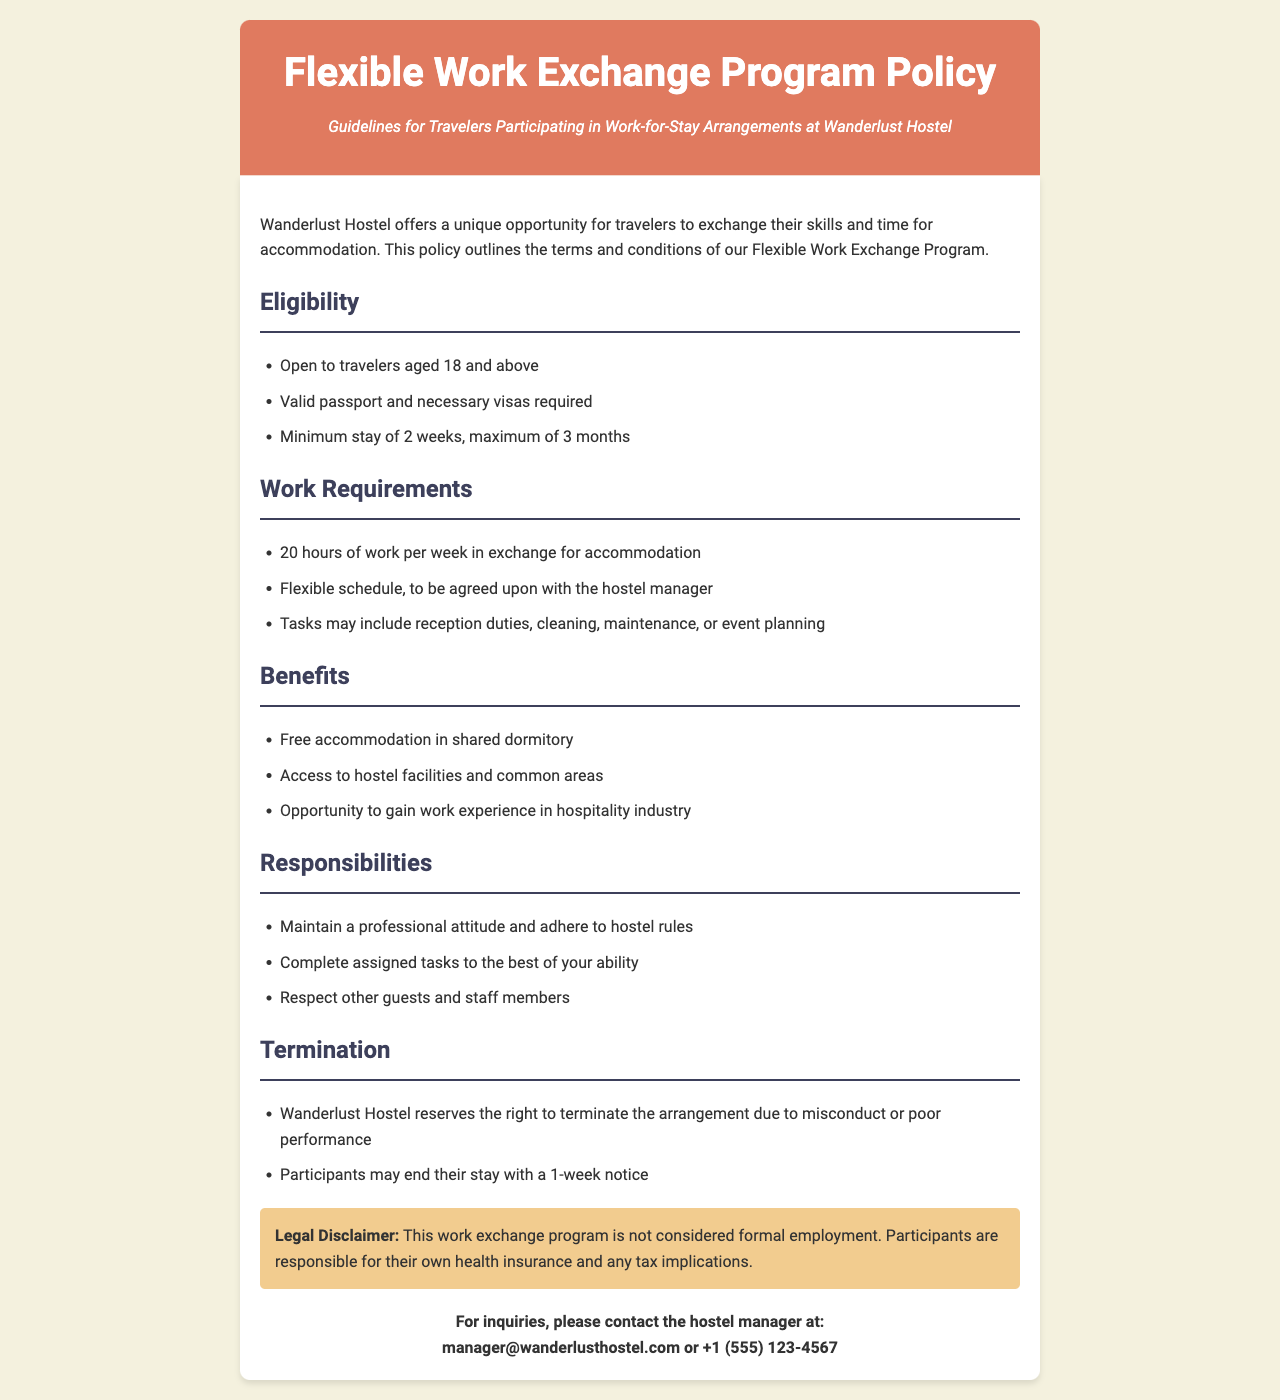What is the minimum stay duration for participants? The document specifies that the minimum stay is 2 weeks.
Answer: 2 weeks How many hours of work are required per week? The Flexible Work Exchange Program requires 20 hours of work per week in exchange for accommodation.
Answer: 20 hours What is the maximum stay duration allowed? According to the policy, the maximum stay duration is 3 months.
Answer: 3 months What types of tasks may participants perform? The document lists tasks such as reception duties, cleaning, maintenance, or event planning.
Answer: reception duties, cleaning, maintenance, or event planning What must participants provide regarding their own health? The legal disclaimer states that participants are responsible for their own health insurance.
Answer: health insurance What is the notice period for ending the stay? The policy requires participants to give a 1-week notice if they wish to end their stay.
Answer: 1-week notice How old must travelers be to participate? The document indicates that travelers must be aged 18 and above to participate in the program.
Answer: 18 What accommodation is provided in exchange for work? The policy states that participants receive free accommodation in a shared dormitory.
Answer: shared dormitory Under what conditions can the hostel terminate the arrangement? The policy indicates that the hostel can terminate the arrangement due to misconduct or poor performance.
Answer: misconduct or poor performance 